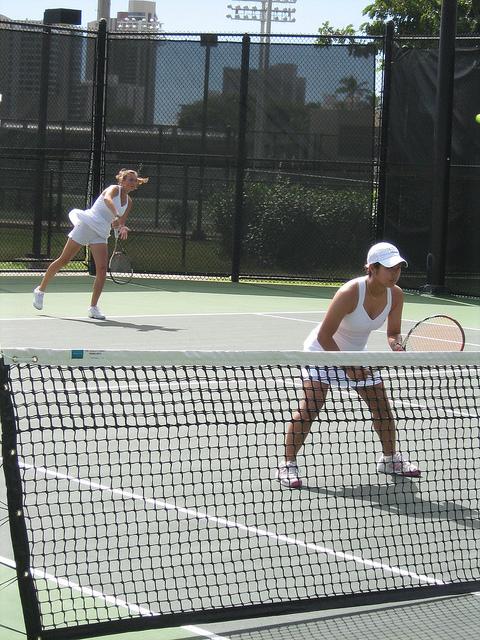What color are the woman wearing?
Short answer required. White. What is shown in the far background of the photo?
Concise answer only. Buildings. What sport are they playing?
Write a very short answer. Tennis. 